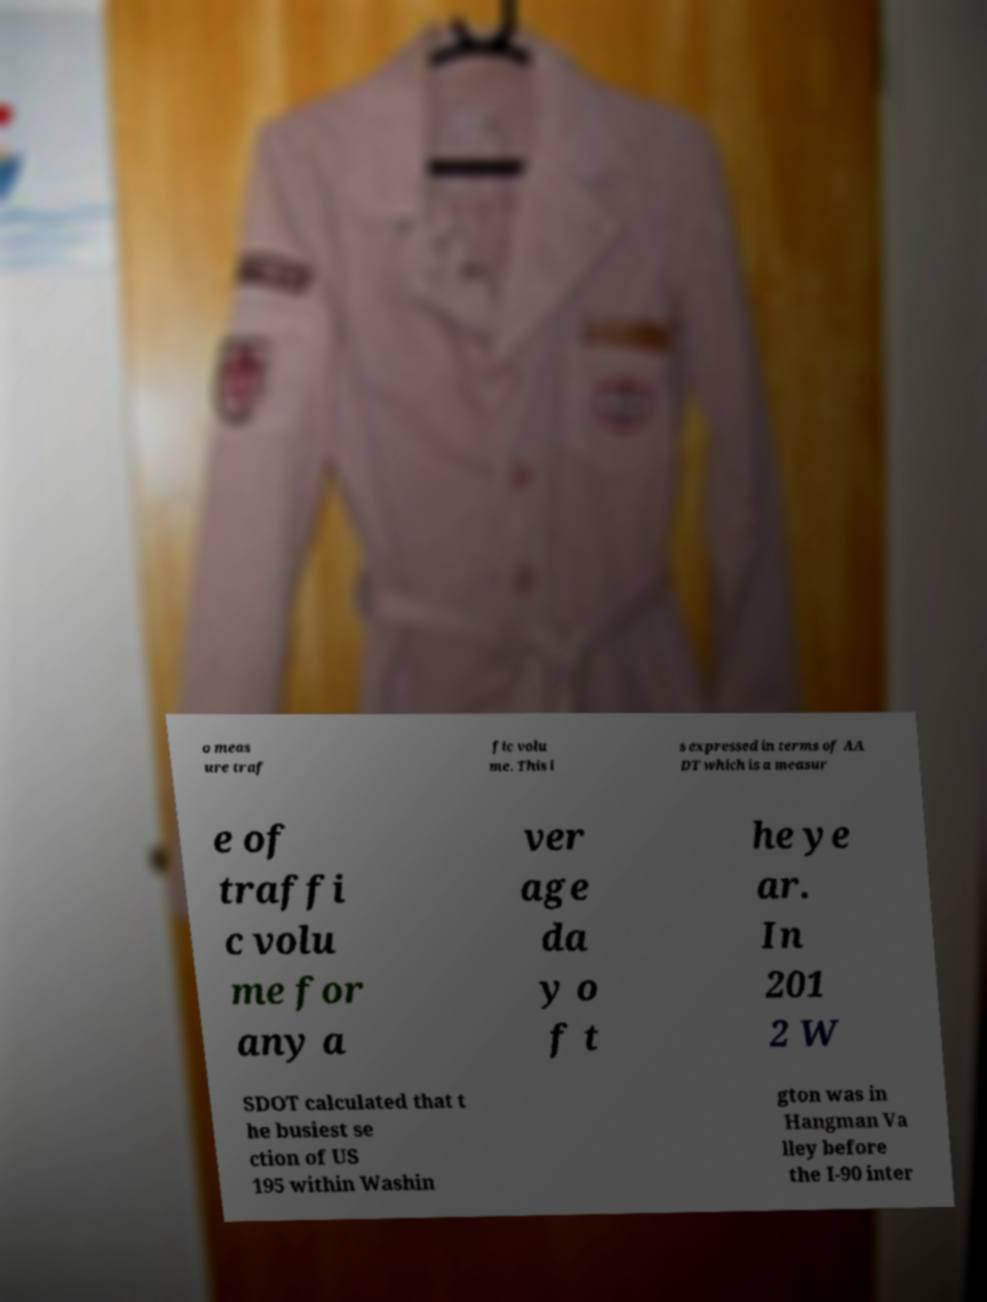What messages or text are displayed in this image? I need them in a readable, typed format. o meas ure traf fic volu me. This i s expressed in terms of AA DT which is a measur e of traffi c volu me for any a ver age da y o f t he ye ar. In 201 2 W SDOT calculated that t he busiest se ction of US 195 within Washin gton was in Hangman Va lley before the I-90 inter 